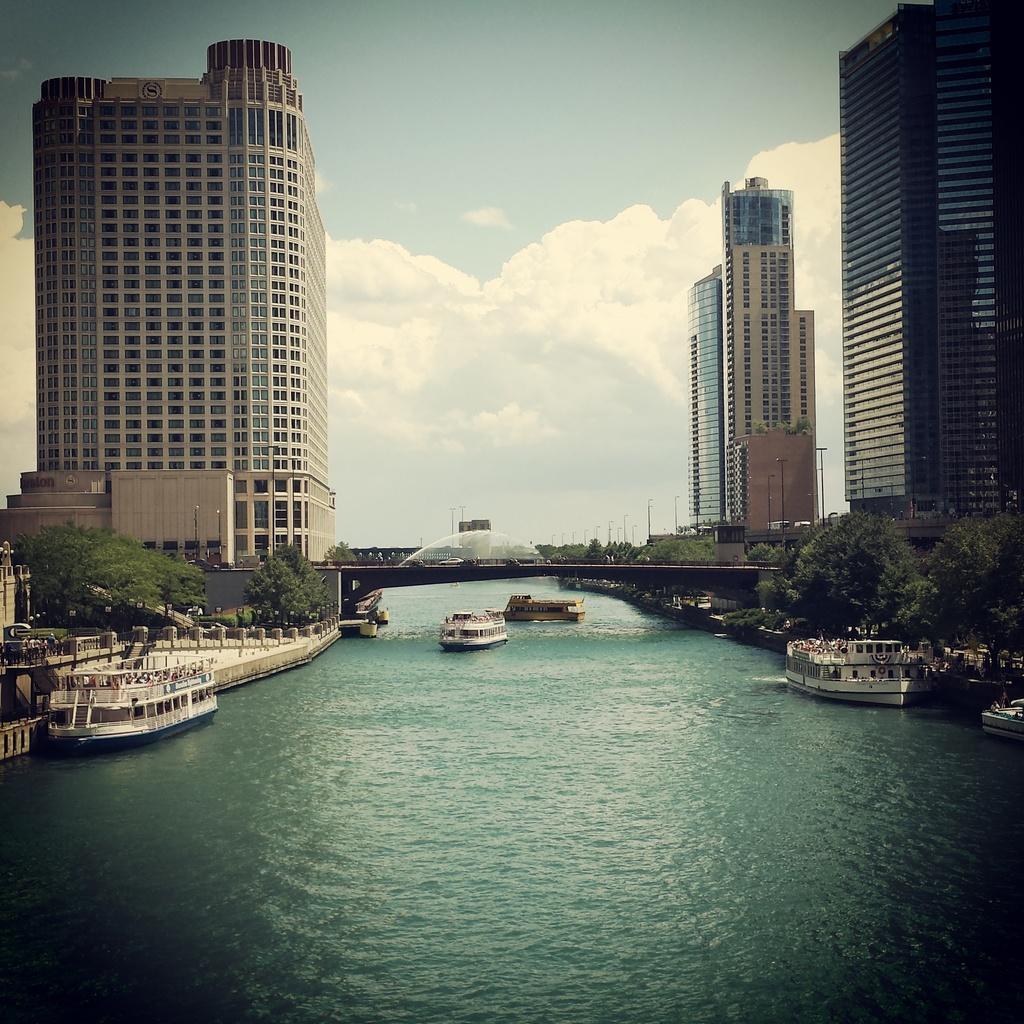Can you describe this image briefly? In this image there are ships on the water. On the left side there is a building and there are trees. On the right side there are buildings and there are trees and the sky is cloudy. 